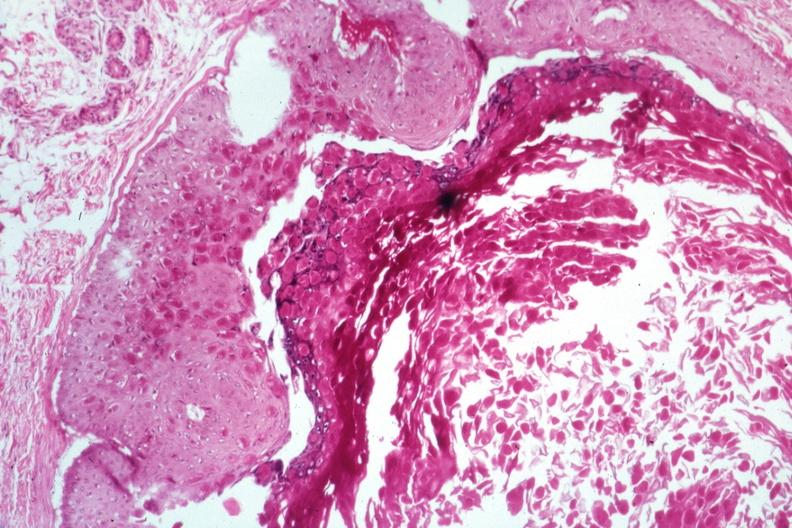does this image show large inclusion bodies well shown?
Answer the question using a single word or phrase. Yes 